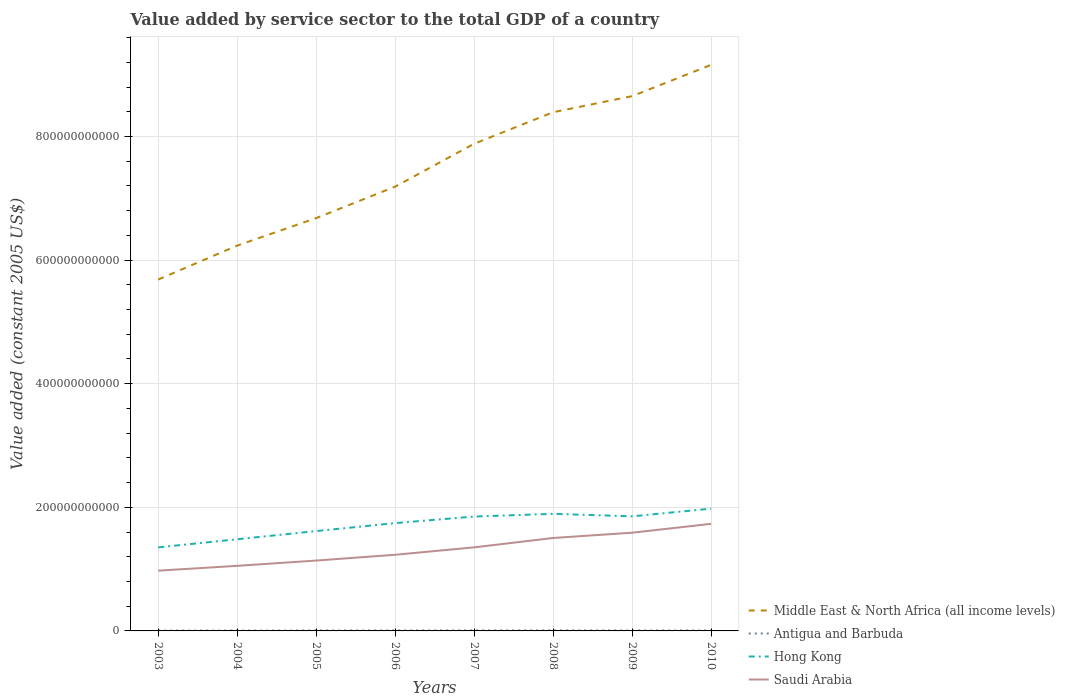How many different coloured lines are there?
Ensure brevity in your answer.  4. Does the line corresponding to Middle East & North Africa (all income levels) intersect with the line corresponding to Antigua and Barbuda?
Your answer should be very brief. No. Is the number of lines equal to the number of legend labels?
Make the answer very short. Yes. Across all years, what is the maximum value added by service sector in Antigua and Barbuda?
Your response must be concise. 6.45e+08. In which year was the value added by service sector in Saudi Arabia maximum?
Your answer should be very brief. 2003. What is the total value added by service sector in Antigua and Barbuda in the graph?
Offer a very short reply. -1.38e+08. What is the difference between the highest and the second highest value added by service sector in Hong Kong?
Your answer should be very brief. 6.27e+1. How many lines are there?
Make the answer very short. 4. What is the difference between two consecutive major ticks on the Y-axis?
Provide a short and direct response. 2.00e+11. Are the values on the major ticks of Y-axis written in scientific E-notation?
Give a very brief answer. No. Does the graph contain grids?
Your answer should be compact. Yes. How many legend labels are there?
Offer a terse response. 4. How are the legend labels stacked?
Your answer should be very brief. Vertical. What is the title of the graph?
Keep it short and to the point. Value added by service sector to the total GDP of a country. What is the label or title of the X-axis?
Give a very brief answer. Years. What is the label or title of the Y-axis?
Provide a short and direct response. Value added (constant 2005 US$). What is the Value added (constant 2005 US$) in Middle East & North Africa (all income levels) in 2003?
Offer a terse response. 5.69e+11. What is the Value added (constant 2005 US$) of Antigua and Barbuda in 2003?
Ensure brevity in your answer.  6.45e+08. What is the Value added (constant 2005 US$) in Hong Kong in 2003?
Keep it short and to the point. 1.35e+11. What is the Value added (constant 2005 US$) in Saudi Arabia in 2003?
Offer a terse response. 9.75e+1. What is the Value added (constant 2005 US$) of Middle East & North Africa (all income levels) in 2004?
Give a very brief answer. 6.23e+11. What is the Value added (constant 2005 US$) of Antigua and Barbuda in 2004?
Keep it short and to the point. 6.69e+08. What is the Value added (constant 2005 US$) in Hong Kong in 2004?
Provide a short and direct response. 1.48e+11. What is the Value added (constant 2005 US$) in Saudi Arabia in 2004?
Make the answer very short. 1.05e+11. What is the Value added (constant 2005 US$) in Middle East & North Africa (all income levels) in 2005?
Keep it short and to the point. 6.68e+11. What is the Value added (constant 2005 US$) of Antigua and Barbuda in 2005?
Provide a succinct answer. 7.00e+08. What is the Value added (constant 2005 US$) of Hong Kong in 2005?
Provide a succinct answer. 1.62e+11. What is the Value added (constant 2005 US$) of Saudi Arabia in 2005?
Give a very brief answer. 1.14e+11. What is the Value added (constant 2005 US$) in Middle East & North Africa (all income levels) in 2006?
Your answer should be very brief. 7.19e+11. What is the Value added (constant 2005 US$) in Antigua and Barbuda in 2006?
Your answer should be compact. 7.54e+08. What is the Value added (constant 2005 US$) of Hong Kong in 2006?
Your answer should be compact. 1.74e+11. What is the Value added (constant 2005 US$) in Saudi Arabia in 2006?
Give a very brief answer. 1.23e+11. What is the Value added (constant 2005 US$) of Middle East & North Africa (all income levels) in 2007?
Your answer should be very brief. 7.88e+11. What is the Value added (constant 2005 US$) in Antigua and Barbuda in 2007?
Keep it short and to the point. 8.07e+08. What is the Value added (constant 2005 US$) of Hong Kong in 2007?
Offer a very short reply. 1.85e+11. What is the Value added (constant 2005 US$) of Saudi Arabia in 2007?
Your answer should be very brief. 1.35e+11. What is the Value added (constant 2005 US$) of Middle East & North Africa (all income levels) in 2008?
Ensure brevity in your answer.  8.39e+11. What is the Value added (constant 2005 US$) in Antigua and Barbuda in 2008?
Offer a very short reply. 8.23e+08. What is the Value added (constant 2005 US$) of Hong Kong in 2008?
Provide a succinct answer. 1.89e+11. What is the Value added (constant 2005 US$) in Saudi Arabia in 2008?
Ensure brevity in your answer.  1.50e+11. What is the Value added (constant 2005 US$) of Middle East & North Africa (all income levels) in 2009?
Your response must be concise. 8.65e+11. What is the Value added (constant 2005 US$) in Antigua and Barbuda in 2009?
Your answer should be compact. 7.27e+08. What is the Value added (constant 2005 US$) of Hong Kong in 2009?
Provide a succinct answer. 1.85e+11. What is the Value added (constant 2005 US$) of Saudi Arabia in 2009?
Offer a terse response. 1.59e+11. What is the Value added (constant 2005 US$) of Middle East & North Africa (all income levels) in 2010?
Provide a succinct answer. 9.16e+11. What is the Value added (constant 2005 US$) in Antigua and Barbuda in 2010?
Give a very brief answer. 7.00e+08. What is the Value added (constant 2005 US$) of Hong Kong in 2010?
Keep it short and to the point. 1.98e+11. What is the Value added (constant 2005 US$) of Saudi Arabia in 2010?
Your answer should be compact. 1.73e+11. Across all years, what is the maximum Value added (constant 2005 US$) of Middle East & North Africa (all income levels)?
Your answer should be compact. 9.16e+11. Across all years, what is the maximum Value added (constant 2005 US$) in Antigua and Barbuda?
Your answer should be very brief. 8.23e+08. Across all years, what is the maximum Value added (constant 2005 US$) in Hong Kong?
Your answer should be compact. 1.98e+11. Across all years, what is the maximum Value added (constant 2005 US$) of Saudi Arabia?
Your response must be concise. 1.73e+11. Across all years, what is the minimum Value added (constant 2005 US$) of Middle East & North Africa (all income levels)?
Your answer should be very brief. 5.69e+11. Across all years, what is the minimum Value added (constant 2005 US$) of Antigua and Barbuda?
Keep it short and to the point. 6.45e+08. Across all years, what is the minimum Value added (constant 2005 US$) of Hong Kong?
Give a very brief answer. 1.35e+11. Across all years, what is the minimum Value added (constant 2005 US$) in Saudi Arabia?
Your response must be concise. 9.75e+1. What is the total Value added (constant 2005 US$) of Middle East & North Africa (all income levels) in the graph?
Your response must be concise. 5.99e+12. What is the total Value added (constant 2005 US$) in Antigua and Barbuda in the graph?
Your answer should be very brief. 5.83e+09. What is the total Value added (constant 2005 US$) in Hong Kong in the graph?
Keep it short and to the point. 1.38e+12. What is the total Value added (constant 2005 US$) in Saudi Arabia in the graph?
Offer a terse response. 1.06e+12. What is the difference between the Value added (constant 2005 US$) in Middle East & North Africa (all income levels) in 2003 and that in 2004?
Ensure brevity in your answer.  -5.49e+1. What is the difference between the Value added (constant 2005 US$) of Antigua and Barbuda in 2003 and that in 2004?
Your response must be concise. -2.36e+07. What is the difference between the Value added (constant 2005 US$) in Hong Kong in 2003 and that in 2004?
Your response must be concise. -1.32e+1. What is the difference between the Value added (constant 2005 US$) in Saudi Arabia in 2003 and that in 2004?
Provide a succinct answer. -7.80e+09. What is the difference between the Value added (constant 2005 US$) in Middle East & North Africa (all income levels) in 2003 and that in 2005?
Give a very brief answer. -9.94e+1. What is the difference between the Value added (constant 2005 US$) of Antigua and Barbuda in 2003 and that in 2005?
Give a very brief answer. -5.47e+07. What is the difference between the Value added (constant 2005 US$) in Hong Kong in 2003 and that in 2005?
Provide a succinct answer. -2.64e+1. What is the difference between the Value added (constant 2005 US$) of Saudi Arabia in 2003 and that in 2005?
Provide a short and direct response. -1.64e+1. What is the difference between the Value added (constant 2005 US$) of Middle East & North Africa (all income levels) in 2003 and that in 2006?
Provide a short and direct response. -1.50e+11. What is the difference between the Value added (constant 2005 US$) of Antigua and Barbuda in 2003 and that in 2006?
Give a very brief answer. -1.09e+08. What is the difference between the Value added (constant 2005 US$) of Hong Kong in 2003 and that in 2006?
Provide a succinct answer. -3.93e+1. What is the difference between the Value added (constant 2005 US$) in Saudi Arabia in 2003 and that in 2006?
Make the answer very short. -2.57e+1. What is the difference between the Value added (constant 2005 US$) of Middle East & North Africa (all income levels) in 2003 and that in 2007?
Make the answer very short. -2.20e+11. What is the difference between the Value added (constant 2005 US$) of Antigua and Barbuda in 2003 and that in 2007?
Ensure brevity in your answer.  -1.61e+08. What is the difference between the Value added (constant 2005 US$) of Hong Kong in 2003 and that in 2007?
Provide a short and direct response. -4.99e+1. What is the difference between the Value added (constant 2005 US$) of Saudi Arabia in 2003 and that in 2007?
Your response must be concise. -3.77e+1. What is the difference between the Value added (constant 2005 US$) of Middle East & North Africa (all income levels) in 2003 and that in 2008?
Give a very brief answer. -2.71e+11. What is the difference between the Value added (constant 2005 US$) of Antigua and Barbuda in 2003 and that in 2008?
Offer a very short reply. -1.78e+08. What is the difference between the Value added (constant 2005 US$) of Hong Kong in 2003 and that in 2008?
Your response must be concise. -5.43e+1. What is the difference between the Value added (constant 2005 US$) in Saudi Arabia in 2003 and that in 2008?
Your answer should be very brief. -5.29e+1. What is the difference between the Value added (constant 2005 US$) of Middle East & North Africa (all income levels) in 2003 and that in 2009?
Your response must be concise. -2.97e+11. What is the difference between the Value added (constant 2005 US$) in Antigua and Barbuda in 2003 and that in 2009?
Offer a terse response. -8.20e+07. What is the difference between the Value added (constant 2005 US$) in Hong Kong in 2003 and that in 2009?
Your response must be concise. -5.02e+1. What is the difference between the Value added (constant 2005 US$) in Saudi Arabia in 2003 and that in 2009?
Give a very brief answer. -6.14e+1. What is the difference between the Value added (constant 2005 US$) in Middle East & North Africa (all income levels) in 2003 and that in 2010?
Offer a very short reply. -3.47e+11. What is the difference between the Value added (constant 2005 US$) in Antigua and Barbuda in 2003 and that in 2010?
Provide a short and direct response. -5.50e+07. What is the difference between the Value added (constant 2005 US$) in Hong Kong in 2003 and that in 2010?
Your response must be concise. -6.27e+1. What is the difference between the Value added (constant 2005 US$) of Saudi Arabia in 2003 and that in 2010?
Offer a very short reply. -7.58e+1. What is the difference between the Value added (constant 2005 US$) in Middle East & North Africa (all income levels) in 2004 and that in 2005?
Your answer should be very brief. -4.45e+1. What is the difference between the Value added (constant 2005 US$) in Antigua and Barbuda in 2004 and that in 2005?
Make the answer very short. -3.11e+07. What is the difference between the Value added (constant 2005 US$) in Hong Kong in 2004 and that in 2005?
Offer a very short reply. -1.32e+1. What is the difference between the Value added (constant 2005 US$) in Saudi Arabia in 2004 and that in 2005?
Ensure brevity in your answer.  -8.56e+09. What is the difference between the Value added (constant 2005 US$) of Middle East & North Africa (all income levels) in 2004 and that in 2006?
Offer a very short reply. -9.54e+1. What is the difference between the Value added (constant 2005 US$) of Antigua and Barbuda in 2004 and that in 2006?
Provide a short and direct response. -8.52e+07. What is the difference between the Value added (constant 2005 US$) in Hong Kong in 2004 and that in 2006?
Offer a terse response. -2.61e+1. What is the difference between the Value added (constant 2005 US$) of Saudi Arabia in 2004 and that in 2006?
Make the answer very short. -1.79e+1. What is the difference between the Value added (constant 2005 US$) of Middle East & North Africa (all income levels) in 2004 and that in 2007?
Provide a succinct answer. -1.65e+11. What is the difference between the Value added (constant 2005 US$) in Antigua and Barbuda in 2004 and that in 2007?
Offer a very short reply. -1.38e+08. What is the difference between the Value added (constant 2005 US$) of Hong Kong in 2004 and that in 2007?
Offer a very short reply. -3.67e+1. What is the difference between the Value added (constant 2005 US$) in Saudi Arabia in 2004 and that in 2007?
Offer a terse response. -2.99e+1. What is the difference between the Value added (constant 2005 US$) in Middle East & North Africa (all income levels) in 2004 and that in 2008?
Give a very brief answer. -2.16e+11. What is the difference between the Value added (constant 2005 US$) in Antigua and Barbuda in 2004 and that in 2008?
Offer a terse response. -1.55e+08. What is the difference between the Value added (constant 2005 US$) in Hong Kong in 2004 and that in 2008?
Keep it short and to the point. -4.11e+1. What is the difference between the Value added (constant 2005 US$) of Saudi Arabia in 2004 and that in 2008?
Keep it short and to the point. -4.51e+1. What is the difference between the Value added (constant 2005 US$) in Middle East & North Africa (all income levels) in 2004 and that in 2009?
Keep it short and to the point. -2.42e+11. What is the difference between the Value added (constant 2005 US$) in Antigua and Barbuda in 2004 and that in 2009?
Your answer should be very brief. -5.84e+07. What is the difference between the Value added (constant 2005 US$) in Hong Kong in 2004 and that in 2009?
Your response must be concise. -3.71e+1. What is the difference between the Value added (constant 2005 US$) of Saudi Arabia in 2004 and that in 2009?
Your answer should be compact. -5.36e+1. What is the difference between the Value added (constant 2005 US$) in Middle East & North Africa (all income levels) in 2004 and that in 2010?
Make the answer very short. -2.92e+11. What is the difference between the Value added (constant 2005 US$) in Antigua and Barbuda in 2004 and that in 2010?
Make the answer very short. -3.14e+07. What is the difference between the Value added (constant 2005 US$) in Hong Kong in 2004 and that in 2010?
Give a very brief answer. -4.95e+1. What is the difference between the Value added (constant 2005 US$) of Saudi Arabia in 2004 and that in 2010?
Offer a very short reply. -6.80e+1. What is the difference between the Value added (constant 2005 US$) of Middle East & North Africa (all income levels) in 2005 and that in 2006?
Your answer should be compact. -5.10e+1. What is the difference between the Value added (constant 2005 US$) in Antigua and Barbuda in 2005 and that in 2006?
Make the answer very short. -5.41e+07. What is the difference between the Value added (constant 2005 US$) of Hong Kong in 2005 and that in 2006?
Keep it short and to the point. -1.29e+1. What is the difference between the Value added (constant 2005 US$) of Saudi Arabia in 2005 and that in 2006?
Make the answer very short. -9.36e+09. What is the difference between the Value added (constant 2005 US$) in Middle East & North Africa (all income levels) in 2005 and that in 2007?
Your answer should be compact. -1.20e+11. What is the difference between the Value added (constant 2005 US$) of Antigua and Barbuda in 2005 and that in 2007?
Offer a terse response. -1.07e+08. What is the difference between the Value added (constant 2005 US$) in Hong Kong in 2005 and that in 2007?
Offer a terse response. -2.35e+1. What is the difference between the Value added (constant 2005 US$) of Saudi Arabia in 2005 and that in 2007?
Offer a terse response. -2.14e+1. What is the difference between the Value added (constant 2005 US$) of Middle East & North Africa (all income levels) in 2005 and that in 2008?
Your answer should be very brief. -1.71e+11. What is the difference between the Value added (constant 2005 US$) of Antigua and Barbuda in 2005 and that in 2008?
Give a very brief answer. -1.24e+08. What is the difference between the Value added (constant 2005 US$) in Hong Kong in 2005 and that in 2008?
Ensure brevity in your answer.  -2.79e+1. What is the difference between the Value added (constant 2005 US$) in Saudi Arabia in 2005 and that in 2008?
Give a very brief answer. -3.65e+1. What is the difference between the Value added (constant 2005 US$) of Middle East & North Africa (all income levels) in 2005 and that in 2009?
Offer a very short reply. -1.97e+11. What is the difference between the Value added (constant 2005 US$) in Antigua and Barbuda in 2005 and that in 2009?
Offer a very short reply. -2.74e+07. What is the difference between the Value added (constant 2005 US$) in Hong Kong in 2005 and that in 2009?
Provide a succinct answer. -2.39e+1. What is the difference between the Value added (constant 2005 US$) of Saudi Arabia in 2005 and that in 2009?
Your response must be concise. -4.51e+1. What is the difference between the Value added (constant 2005 US$) in Middle East & North Africa (all income levels) in 2005 and that in 2010?
Keep it short and to the point. -2.48e+11. What is the difference between the Value added (constant 2005 US$) in Antigua and Barbuda in 2005 and that in 2010?
Your answer should be compact. -2.72e+05. What is the difference between the Value added (constant 2005 US$) of Hong Kong in 2005 and that in 2010?
Give a very brief answer. -3.63e+1. What is the difference between the Value added (constant 2005 US$) of Saudi Arabia in 2005 and that in 2010?
Your response must be concise. -5.94e+1. What is the difference between the Value added (constant 2005 US$) in Middle East & North Africa (all income levels) in 2006 and that in 2007?
Your response must be concise. -6.94e+1. What is the difference between the Value added (constant 2005 US$) in Antigua and Barbuda in 2006 and that in 2007?
Ensure brevity in your answer.  -5.26e+07. What is the difference between the Value added (constant 2005 US$) in Hong Kong in 2006 and that in 2007?
Your response must be concise. -1.06e+1. What is the difference between the Value added (constant 2005 US$) of Saudi Arabia in 2006 and that in 2007?
Give a very brief answer. -1.20e+1. What is the difference between the Value added (constant 2005 US$) in Middle East & North Africa (all income levels) in 2006 and that in 2008?
Keep it short and to the point. -1.20e+11. What is the difference between the Value added (constant 2005 US$) of Antigua and Barbuda in 2006 and that in 2008?
Provide a short and direct response. -6.95e+07. What is the difference between the Value added (constant 2005 US$) of Hong Kong in 2006 and that in 2008?
Your response must be concise. -1.50e+1. What is the difference between the Value added (constant 2005 US$) of Saudi Arabia in 2006 and that in 2008?
Provide a short and direct response. -2.72e+1. What is the difference between the Value added (constant 2005 US$) of Middle East & North Africa (all income levels) in 2006 and that in 2009?
Provide a succinct answer. -1.46e+11. What is the difference between the Value added (constant 2005 US$) in Antigua and Barbuda in 2006 and that in 2009?
Offer a terse response. 2.68e+07. What is the difference between the Value added (constant 2005 US$) in Hong Kong in 2006 and that in 2009?
Your answer should be compact. -1.10e+1. What is the difference between the Value added (constant 2005 US$) of Saudi Arabia in 2006 and that in 2009?
Offer a terse response. -3.57e+1. What is the difference between the Value added (constant 2005 US$) in Middle East & North Africa (all income levels) in 2006 and that in 2010?
Give a very brief answer. -1.97e+11. What is the difference between the Value added (constant 2005 US$) of Antigua and Barbuda in 2006 and that in 2010?
Keep it short and to the point. 5.38e+07. What is the difference between the Value added (constant 2005 US$) of Hong Kong in 2006 and that in 2010?
Offer a terse response. -2.34e+1. What is the difference between the Value added (constant 2005 US$) in Saudi Arabia in 2006 and that in 2010?
Your answer should be very brief. -5.01e+1. What is the difference between the Value added (constant 2005 US$) in Middle East & North Africa (all income levels) in 2007 and that in 2008?
Offer a very short reply. -5.10e+1. What is the difference between the Value added (constant 2005 US$) of Antigua and Barbuda in 2007 and that in 2008?
Your answer should be compact. -1.68e+07. What is the difference between the Value added (constant 2005 US$) of Hong Kong in 2007 and that in 2008?
Your response must be concise. -4.39e+09. What is the difference between the Value added (constant 2005 US$) of Saudi Arabia in 2007 and that in 2008?
Give a very brief answer. -1.52e+1. What is the difference between the Value added (constant 2005 US$) of Middle East & North Africa (all income levels) in 2007 and that in 2009?
Provide a succinct answer. -7.70e+1. What is the difference between the Value added (constant 2005 US$) in Antigua and Barbuda in 2007 and that in 2009?
Ensure brevity in your answer.  7.94e+07. What is the difference between the Value added (constant 2005 US$) of Hong Kong in 2007 and that in 2009?
Offer a terse response. -3.63e+08. What is the difference between the Value added (constant 2005 US$) of Saudi Arabia in 2007 and that in 2009?
Your response must be concise. -2.37e+1. What is the difference between the Value added (constant 2005 US$) of Middle East & North Africa (all income levels) in 2007 and that in 2010?
Your answer should be very brief. -1.28e+11. What is the difference between the Value added (constant 2005 US$) of Antigua and Barbuda in 2007 and that in 2010?
Your answer should be compact. 1.06e+08. What is the difference between the Value added (constant 2005 US$) of Hong Kong in 2007 and that in 2010?
Your answer should be compact. -1.28e+1. What is the difference between the Value added (constant 2005 US$) of Saudi Arabia in 2007 and that in 2010?
Provide a short and direct response. -3.81e+1. What is the difference between the Value added (constant 2005 US$) in Middle East & North Africa (all income levels) in 2008 and that in 2009?
Make the answer very short. -2.60e+1. What is the difference between the Value added (constant 2005 US$) of Antigua and Barbuda in 2008 and that in 2009?
Ensure brevity in your answer.  9.62e+07. What is the difference between the Value added (constant 2005 US$) in Hong Kong in 2008 and that in 2009?
Give a very brief answer. 4.03e+09. What is the difference between the Value added (constant 2005 US$) in Saudi Arabia in 2008 and that in 2009?
Provide a short and direct response. -8.54e+09. What is the difference between the Value added (constant 2005 US$) in Middle East & North Africa (all income levels) in 2008 and that in 2010?
Give a very brief answer. -7.66e+1. What is the difference between the Value added (constant 2005 US$) in Antigua and Barbuda in 2008 and that in 2010?
Your response must be concise. 1.23e+08. What is the difference between the Value added (constant 2005 US$) of Hong Kong in 2008 and that in 2010?
Provide a succinct answer. -8.41e+09. What is the difference between the Value added (constant 2005 US$) of Saudi Arabia in 2008 and that in 2010?
Provide a succinct answer. -2.29e+1. What is the difference between the Value added (constant 2005 US$) in Middle East & North Africa (all income levels) in 2009 and that in 2010?
Ensure brevity in your answer.  -5.06e+1. What is the difference between the Value added (constant 2005 US$) in Antigua and Barbuda in 2009 and that in 2010?
Make the answer very short. 2.71e+07. What is the difference between the Value added (constant 2005 US$) in Hong Kong in 2009 and that in 2010?
Offer a very short reply. -1.24e+1. What is the difference between the Value added (constant 2005 US$) of Saudi Arabia in 2009 and that in 2010?
Give a very brief answer. -1.43e+1. What is the difference between the Value added (constant 2005 US$) of Middle East & North Africa (all income levels) in 2003 and the Value added (constant 2005 US$) of Antigua and Barbuda in 2004?
Make the answer very short. 5.68e+11. What is the difference between the Value added (constant 2005 US$) of Middle East & North Africa (all income levels) in 2003 and the Value added (constant 2005 US$) of Hong Kong in 2004?
Your answer should be compact. 4.20e+11. What is the difference between the Value added (constant 2005 US$) in Middle East & North Africa (all income levels) in 2003 and the Value added (constant 2005 US$) in Saudi Arabia in 2004?
Keep it short and to the point. 4.63e+11. What is the difference between the Value added (constant 2005 US$) of Antigua and Barbuda in 2003 and the Value added (constant 2005 US$) of Hong Kong in 2004?
Offer a terse response. -1.48e+11. What is the difference between the Value added (constant 2005 US$) in Antigua and Barbuda in 2003 and the Value added (constant 2005 US$) in Saudi Arabia in 2004?
Provide a short and direct response. -1.05e+11. What is the difference between the Value added (constant 2005 US$) of Hong Kong in 2003 and the Value added (constant 2005 US$) of Saudi Arabia in 2004?
Offer a very short reply. 2.99e+1. What is the difference between the Value added (constant 2005 US$) in Middle East & North Africa (all income levels) in 2003 and the Value added (constant 2005 US$) in Antigua and Barbuda in 2005?
Provide a succinct answer. 5.68e+11. What is the difference between the Value added (constant 2005 US$) of Middle East & North Africa (all income levels) in 2003 and the Value added (constant 2005 US$) of Hong Kong in 2005?
Ensure brevity in your answer.  4.07e+11. What is the difference between the Value added (constant 2005 US$) in Middle East & North Africa (all income levels) in 2003 and the Value added (constant 2005 US$) in Saudi Arabia in 2005?
Your answer should be compact. 4.55e+11. What is the difference between the Value added (constant 2005 US$) of Antigua and Barbuda in 2003 and the Value added (constant 2005 US$) of Hong Kong in 2005?
Your answer should be very brief. -1.61e+11. What is the difference between the Value added (constant 2005 US$) in Antigua and Barbuda in 2003 and the Value added (constant 2005 US$) in Saudi Arabia in 2005?
Offer a very short reply. -1.13e+11. What is the difference between the Value added (constant 2005 US$) in Hong Kong in 2003 and the Value added (constant 2005 US$) in Saudi Arabia in 2005?
Make the answer very short. 2.13e+1. What is the difference between the Value added (constant 2005 US$) of Middle East & North Africa (all income levels) in 2003 and the Value added (constant 2005 US$) of Antigua and Barbuda in 2006?
Make the answer very short. 5.68e+11. What is the difference between the Value added (constant 2005 US$) of Middle East & North Africa (all income levels) in 2003 and the Value added (constant 2005 US$) of Hong Kong in 2006?
Provide a succinct answer. 3.94e+11. What is the difference between the Value added (constant 2005 US$) in Middle East & North Africa (all income levels) in 2003 and the Value added (constant 2005 US$) in Saudi Arabia in 2006?
Offer a very short reply. 4.45e+11. What is the difference between the Value added (constant 2005 US$) in Antigua and Barbuda in 2003 and the Value added (constant 2005 US$) in Hong Kong in 2006?
Make the answer very short. -1.74e+11. What is the difference between the Value added (constant 2005 US$) of Antigua and Barbuda in 2003 and the Value added (constant 2005 US$) of Saudi Arabia in 2006?
Give a very brief answer. -1.23e+11. What is the difference between the Value added (constant 2005 US$) in Hong Kong in 2003 and the Value added (constant 2005 US$) in Saudi Arabia in 2006?
Provide a short and direct response. 1.20e+1. What is the difference between the Value added (constant 2005 US$) in Middle East & North Africa (all income levels) in 2003 and the Value added (constant 2005 US$) in Antigua and Barbuda in 2007?
Give a very brief answer. 5.68e+11. What is the difference between the Value added (constant 2005 US$) in Middle East & North Africa (all income levels) in 2003 and the Value added (constant 2005 US$) in Hong Kong in 2007?
Give a very brief answer. 3.83e+11. What is the difference between the Value added (constant 2005 US$) in Middle East & North Africa (all income levels) in 2003 and the Value added (constant 2005 US$) in Saudi Arabia in 2007?
Offer a terse response. 4.33e+11. What is the difference between the Value added (constant 2005 US$) of Antigua and Barbuda in 2003 and the Value added (constant 2005 US$) of Hong Kong in 2007?
Give a very brief answer. -1.84e+11. What is the difference between the Value added (constant 2005 US$) in Antigua and Barbuda in 2003 and the Value added (constant 2005 US$) in Saudi Arabia in 2007?
Ensure brevity in your answer.  -1.35e+11. What is the difference between the Value added (constant 2005 US$) in Hong Kong in 2003 and the Value added (constant 2005 US$) in Saudi Arabia in 2007?
Offer a terse response. -2.84e+07. What is the difference between the Value added (constant 2005 US$) of Middle East & North Africa (all income levels) in 2003 and the Value added (constant 2005 US$) of Antigua and Barbuda in 2008?
Provide a succinct answer. 5.68e+11. What is the difference between the Value added (constant 2005 US$) in Middle East & North Africa (all income levels) in 2003 and the Value added (constant 2005 US$) in Hong Kong in 2008?
Offer a very short reply. 3.79e+11. What is the difference between the Value added (constant 2005 US$) in Middle East & North Africa (all income levels) in 2003 and the Value added (constant 2005 US$) in Saudi Arabia in 2008?
Provide a succinct answer. 4.18e+11. What is the difference between the Value added (constant 2005 US$) in Antigua and Barbuda in 2003 and the Value added (constant 2005 US$) in Hong Kong in 2008?
Your answer should be very brief. -1.89e+11. What is the difference between the Value added (constant 2005 US$) in Antigua and Barbuda in 2003 and the Value added (constant 2005 US$) in Saudi Arabia in 2008?
Ensure brevity in your answer.  -1.50e+11. What is the difference between the Value added (constant 2005 US$) of Hong Kong in 2003 and the Value added (constant 2005 US$) of Saudi Arabia in 2008?
Ensure brevity in your answer.  -1.52e+1. What is the difference between the Value added (constant 2005 US$) in Middle East & North Africa (all income levels) in 2003 and the Value added (constant 2005 US$) in Antigua and Barbuda in 2009?
Ensure brevity in your answer.  5.68e+11. What is the difference between the Value added (constant 2005 US$) of Middle East & North Africa (all income levels) in 2003 and the Value added (constant 2005 US$) of Hong Kong in 2009?
Keep it short and to the point. 3.83e+11. What is the difference between the Value added (constant 2005 US$) of Middle East & North Africa (all income levels) in 2003 and the Value added (constant 2005 US$) of Saudi Arabia in 2009?
Make the answer very short. 4.10e+11. What is the difference between the Value added (constant 2005 US$) of Antigua and Barbuda in 2003 and the Value added (constant 2005 US$) of Hong Kong in 2009?
Your answer should be compact. -1.85e+11. What is the difference between the Value added (constant 2005 US$) of Antigua and Barbuda in 2003 and the Value added (constant 2005 US$) of Saudi Arabia in 2009?
Provide a short and direct response. -1.58e+11. What is the difference between the Value added (constant 2005 US$) of Hong Kong in 2003 and the Value added (constant 2005 US$) of Saudi Arabia in 2009?
Offer a terse response. -2.37e+1. What is the difference between the Value added (constant 2005 US$) in Middle East & North Africa (all income levels) in 2003 and the Value added (constant 2005 US$) in Antigua and Barbuda in 2010?
Your response must be concise. 5.68e+11. What is the difference between the Value added (constant 2005 US$) of Middle East & North Africa (all income levels) in 2003 and the Value added (constant 2005 US$) of Hong Kong in 2010?
Provide a short and direct response. 3.71e+11. What is the difference between the Value added (constant 2005 US$) in Middle East & North Africa (all income levels) in 2003 and the Value added (constant 2005 US$) in Saudi Arabia in 2010?
Offer a very short reply. 3.95e+11. What is the difference between the Value added (constant 2005 US$) in Antigua and Barbuda in 2003 and the Value added (constant 2005 US$) in Hong Kong in 2010?
Ensure brevity in your answer.  -1.97e+11. What is the difference between the Value added (constant 2005 US$) in Antigua and Barbuda in 2003 and the Value added (constant 2005 US$) in Saudi Arabia in 2010?
Offer a terse response. -1.73e+11. What is the difference between the Value added (constant 2005 US$) of Hong Kong in 2003 and the Value added (constant 2005 US$) of Saudi Arabia in 2010?
Provide a succinct answer. -3.81e+1. What is the difference between the Value added (constant 2005 US$) of Middle East & North Africa (all income levels) in 2004 and the Value added (constant 2005 US$) of Antigua and Barbuda in 2005?
Offer a very short reply. 6.23e+11. What is the difference between the Value added (constant 2005 US$) of Middle East & North Africa (all income levels) in 2004 and the Value added (constant 2005 US$) of Hong Kong in 2005?
Your response must be concise. 4.62e+11. What is the difference between the Value added (constant 2005 US$) in Middle East & North Africa (all income levels) in 2004 and the Value added (constant 2005 US$) in Saudi Arabia in 2005?
Provide a short and direct response. 5.10e+11. What is the difference between the Value added (constant 2005 US$) in Antigua and Barbuda in 2004 and the Value added (constant 2005 US$) in Hong Kong in 2005?
Give a very brief answer. -1.61e+11. What is the difference between the Value added (constant 2005 US$) of Antigua and Barbuda in 2004 and the Value added (constant 2005 US$) of Saudi Arabia in 2005?
Your answer should be very brief. -1.13e+11. What is the difference between the Value added (constant 2005 US$) in Hong Kong in 2004 and the Value added (constant 2005 US$) in Saudi Arabia in 2005?
Keep it short and to the point. 3.45e+1. What is the difference between the Value added (constant 2005 US$) in Middle East & North Africa (all income levels) in 2004 and the Value added (constant 2005 US$) in Antigua and Barbuda in 2006?
Your response must be concise. 6.23e+11. What is the difference between the Value added (constant 2005 US$) of Middle East & North Africa (all income levels) in 2004 and the Value added (constant 2005 US$) of Hong Kong in 2006?
Provide a short and direct response. 4.49e+11. What is the difference between the Value added (constant 2005 US$) of Middle East & North Africa (all income levels) in 2004 and the Value added (constant 2005 US$) of Saudi Arabia in 2006?
Your answer should be very brief. 5.00e+11. What is the difference between the Value added (constant 2005 US$) of Antigua and Barbuda in 2004 and the Value added (constant 2005 US$) of Hong Kong in 2006?
Ensure brevity in your answer.  -1.74e+11. What is the difference between the Value added (constant 2005 US$) in Antigua and Barbuda in 2004 and the Value added (constant 2005 US$) in Saudi Arabia in 2006?
Give a very brief answer. -1.23e+11. What is the difference between the Value added (constant 2005 US$) in Hong Kong in 2004 and the Value added (constant 2005 US$) in Saudi Arabia in 2006?
Provide a succinct answer. 2.51e+1. What is the difference between the Value added (constant 2005 US$) in Middle East & North Africa (all income levels) in 2004 and the Value added (constant 2005 US$) in Antigua and Barbuda in 2007?
Make the answer very short. 6.23e+11. What is the difference between the Value added (constant 2005 US$) in Middle East & North Africa (all income levels) in 2004 and the Value added (constant 2005 US$) in Hong Kong in 2007?
Offer a very short reply. 4.38e+11. What is the difference between the Value added (constant 2005 US$) in Middle East & North Africa (all income levels) in 2004 and the Value added (constant 2005 US$) in Saudi Arabia in 2007?
Provide a short and direct response. 4.88e+11. What is the difference between the Value added (constant 2005 US$) of Antigua and Barbuda in 2004 and the Value added (constant 2005 US$) of Hong Kong in 2007?
Keep it short and to the point. -1.84e+11. What is the difference between the Value added (constant 2005 US$) in Antigua and Barbuda in 2004 and the Value added (constant 2005 US$) in Saudi Arabia in 2007?
Your response must be concise. -1.35e+11. What is the difference between the Value added (constant 2005 US$) in Hong Kong in 2004 and the Value added (constant 2005 US$) in Saudi Arabia in 2007?
Your answer should be very brief. 1.31e+1. What is the difference between the Value added (constant 2005 US$) of Middle East & North Africa (all income levels) in 2004 and the Value added (constant 2005 US$) of Antigua and Barbuda in 2008?
Provide a succinct answer. 6.23e+11. What is the difference between the Value added (constant 2005 US$) of Middle East & North Africa (all income levels) in 2004 and the Value added (constant 2005 US$) of Hong Kong in 2008?
Provide a short and direct response. 4.34e+11. What is the difference between the Value added (constant 2005 US$) of Middle East & North Africa (all income levels) in 2004 and the Value added (constant 2005 US$) of Saudi Arabia in 2008?
Provide a succinct answer. 4.73e+11. What is the difference between the Value added (constant 2005 US$) in Antigua and Barbuda in 2004 and the Value added (constant 2005 US$) in Hong Kong in 2008?
Ensure brevity in your answer.  -1.89e+11. What is the difference between the Value added (constant 2005 US$) of Antigua and Barbuda in 2004 and the Value added (constant 2005 US$) of Saudi Arabia in 2008?
Your answer should be compact. -1.50e+11. What is the difference between the Value added (constant 2005 US$) in Hong Kong in 2004 and the Value added (constant 2005 US$) in Saudi Arabia in 2008?
Offer a very short reply. -2.04e+09. What is the difference between the Value added (constant 2005 US$) in Middle East & North Africa (all income levels) in 2004 and the Value added (constant 2005 US$) in Antigua and Barbuda in 2009?
Give a very brief answer. 6.23e+11. What is the difference between the Value added (constant 2005 US$) in Middle East & North Africa (all income levels) in 2004 and the Value added (constant 2005 US$) in Hong Kong in 2009?
Your answer should be very brief. 4.38e+11. What is the difference between the Value added (constant 2005 US$) in Middle East & North Africa (all income levels) in 2004 and the Value added (constant 2005 US$) in Saudi Arabia in 2009?
Provide a short and direct response. 4.65e+11. What is the difference between the Value added (constant 2005 US$) in Antigua and Barbuda in 2004 and the Value added (constant 2005 US$) in Hong Kong in 2009?
Keep it short and to the point. -1.85e+11. What is the difference between the Value added (constant 2005 US$) of Antigua and Barbuda in 2004 and the Value added (constant 2005 US$) of Saudi Arabia in 2009?
Your answer should be compact. -1.58e+11. What is the difference between the Value added (constant 2005 US$) of Hong Kong in 2004 and the Value added (constant 2005 US$) of Saudi Arabia in 2009?
Offer a terse response. -1.06e+1. What is the difference between the Value added (constant 2005 US$) in Middle East & North Africa (all income levels) in 2004 and the Value added (constant 2005 US$) in Antigua and Barbuda in 2010?
Provide a short and direct response. 6.23e+11. What is the difference between the Value added (constant 2005 US$) in Middle East & North Africa (all income levels) in 2004 and the Value added (constant 2005 US$) in Hong Kong in 2010?
Your answer should be very brief. 4.26e+11. What is the difference between the Value added (constant 2005 US$) of Middle East & North Africa (all income levels) in 2004 and the Value added (constant 2005 US$) of Saudi Arabia in 2010?
Offer a terse response. 4.50e+11. What is the difference between the Value added (constant 2005 US$) of Antigua and Barbuda in 2004 and the Value added (constant 2005 US$) of Hong Kong in 2010?
Ensure brevity in your answer.  -1.97e+11. What is the difference between the Value added (constant 2005 US$) in Antigua and Barbuda in 2004 and the Value added (constant 2005 US$) in Saudi Arabia in 2010?
Provide a short and direct response. -1.73e+11. What is the difference between the Value added (constant 2005 US$) of Hong Kong in 2004 and the Value added (constant 2005 US$) of Saudi Arabia in 2010?
Give a very brief answer. -2.49e+1. What is the difference between the Value added (constant 2005 US$) in Middle East & North Africa (all income levels) in 2005 and the Value added (constant 2005 US$) in Antigua and Barbuda in 2006?
Ensure brevity in your answer.  6.67e+11. What is the difference between the Value added (constant 2005 US$) of Middle East & North Africa (all income levels) in 2005 and the Value added (constant 2005 US$) of Hong Kong in 2006?
Give a very brief answer. 4.93e+11. What is the difference between the Value added (constant 2005 US$) in Middle East & North Africa (all income levels) in 2005 and the Value added (constant 2005 US$) in Saudi Arabia in 2006?
Ensure brevity in your answer.  5.45e+11. What is the difference between the Value added (constant 2005 US$) in Antigua and Barbuda in 2005 and the Value added (constant 2005 US$) in Hong Kong in 2006?
Your response must be concise. -1.74e+11. What is the difference between the Value added (constant 2005 US$) in Antigua and Barbuda in 2005 and the Value added (constant 2005 US$) in Saudi Arabia in 2006?
Your response must be concise. -1.23e+11. What is the difference between the Value added (constant 2005 US$) in Hong Kong in 2005 and the Value added (constant 2005 US$) in Saudi Arabia in 2006?
Offer a terse response. 3.83e+1. What is the difference between the Value added (constant 2005 US$) of Middle East & North Africa (all income levels) in 2005 and the Value added (constant 2005 US$) of Antigua and Barbuda in 2007?
Your answer should be compact. 6.67e+11. What is the difference between the Value added (constant 2005 US$) of Middle East & North Africa (all income levels) in 2005 and the Value added (constant 2005 US$) of Hong Kong in 2007?
Give a very brief answer. 4.83e+11. What is the difference between the Value added (constant 2005 US$) in Middle East & North Africa (all income levels) in 2005 and the Value added (constant 2005 US$) in Saudi Arabia in 2007?
Make the answer very short. 5.33e+11. What is the difference between the Value added (constant 2005 US$) in Antigua and Barbuda in 2005 and the Value added (constant 2005 US$) in Hong Kong in 2007?
Provide a short and direct response. -1.84e+11. What is the difference between the Value added (constant 2005 US$) of Antigua and Barbuda in 2005 and the Value added (constant 2005 US$) of Saudi Arabia in 2007?
Give a very brief answer. -1.35e+11. What is the difference between the Value added (constant 2005 US$) in Hong Kong in 2005 and the Value added (constant 2005 US$) in Saudi Arabia in 2007?
Offer a very short reply. 2.63e+1. What is the difference between the Value added (constant 2005 US$) in Middle East & North Africa (all income levels) in 2005 and the Value added (constant 2005 US$) in Antigua and Barbuda in 2008?
Your answer should be compact. 6.67e+11. What is the difference between the Value added (constant 2005 US$) of Middle East & North Africa (all income levels) in 2005 and the Value added (constant 2005 US$) of Hong Kong in 2008?
Ensure brevity in your answer.  4.78e+11. What is the difference between the Value added (constant 2005 US$) in Middle East & North Africa (all income levels) in 2005 and the Value added (constant 2005 US$) in Saudi Arabia in 2008?
Your answer should be compact. 5.18e+11. What is the difference between the Value added (constant 2005 US$) of Antigua and Barbuda in 2005 and the Value added (constant 2005 US$) of Hong Kong in 2008?
Your response must be concise. -1.89e+11. What is the difference between the Value added (constant 2005 US$) in Antigua and Barbuda in 2005 and the Value added (constant 2005 US$) in Saudi Arabia in 2008?
Your answer should be very brief. -1.50e+11. What is the difference between the Value added (constant 2005 US$) in Hong Kong in 2005 and the Value added (constant 2005 US$) in Saudi Arabia in 2008?
Make the answer very short. 1.12e+1. What is the difference between the Value added (constant 2005 US$) in Middle East & North Africa (all income levels) in 2005 and the Value added (constant 2005 US$) in Antigua and Barbuda in 2009?
Offer a very short reply. 6.67e+11. What is the difference between the Value added (constant 2005 US$) of Middle East & North Africa (all income levels) in 2005 and the Value added (constant 2005 US$) of Hong Kong in 2009?
Give a very brief answer. 4.83e+11. What is the difference between the Value added (constant 2005 US$) in Middle East & North Africa (all income levels) in 2005 and the Value added (constant 2005 US$) in Saudi Arabia in 2009?
Your answer should be compact. 5.09e+11. What is the difference between the Value added (constant 2005 US$) of Antigua and Barbuda in 2005 and the Value added (constant 2005 US$) of Hong Kong in 2009?
Keep it short and to the point. -1.85e+11. What is the difference between the Value added (constant 2005 US$) of Antigua and Barbuda in 2005 and the Value added (constant 2005 US$) of Saudi Arabia in 2009?
Give a very brief answer. -1.58e+11. What is the difference between the Value added (constant 2005 US$) in Hong Kong in 2005 and the Value added (constant 2005 US$) in Saudi Arabia in 2009?
Provide a succinct answer. 2.63e+09. What is the difference between the Value added (constant 2005 US$) of Middle East & North Africa (all income levels) in 2005 and the Value added (constant 2005 US$) of Antigua and Barbuda in 2010?
Your answer should be compact. 6.67e+11. What is the difference between the Value added (constant 2005 US$) in Middle East & North Africa (all income levels) in 2005 and the Value added (constant 2005 US$) in Hong Kong in 2010?
Provide a short and direct response. 4.70e+11. What is the difference between the Value added (constant 2005 US$) of Middle East & North Africa (all income levels) in 2005 and the Value added (constant 2005 US$) of Saudi Arabia in 2010?
Your answer should be compact. 4.95e+11. What is the difference between the Value added (constant 2005 US$) in Antigua and Barbuda in 2005 and the Value added (constant 2005 US$) in Hong Kong in 2010?
Your answer should be compact. -1.97e+11. What is the difference between the Value added (constant 2005 US$) of Antigua and Barbuda in 2005 and the Value added (constant 2005 US$) of Saudi Arabia in 2010?
Your answer should be compact. -1.73e+11. What is the difference between the Value added (constant 2005 US$) of Hong Kong in 2005 and the Value added (constant 2005 US$) of Saudi Arabia in 2010?
Your answer should be compact. -1.17e+1. What is the difference between the Value added (constant 2005 US$) of Middle East & North Africa (all income levels) in 2006 and the Value added (constant 2005 US$) of Antigua and Barbuda in 2007?
Ensure brevity in your answer.  7.18e+11. What is the difference between the Value added (constant 2005 US$) in Middle East & North Africa (all income levels) in 2006 and the Value added (constant 2005 US$) in Hong Kong in 2007?
Offer a very short reply. 5.34e+11. What is the difference between the Value added (constant 2005 US$) of Middle East & North Africa (all income levels) in 2006 and the Value added (constant 2005 US$) of Saudi Arabia in 2007?
Provide a succinct answer. 5.84e+11. What is the difference between the Value added (constant 2005 US$) of Antigua and Barbuda in 2006 and the Value added (constant 2005 US$) of Hong Kong in 2007?
Your response must be concise. -1.84e+11. What is the difference between the Value added (constant 2005 US$) of Antigua and Barbuda in 2006 and the Value added (constant 2005 US$) of Saudi Arabia in 2007?
Ensure brevity in your answer.  -1.34e+11. What is the difference between the Value added (constant 2005 US$) of Hong Kong in 2006 and the Value added (constant 2005 US$) of Saudi Arabia in 2007?
Provide a succinct answer. 3.93e+1. What is the difference between the Value added (constant 2005 US$) of Middle East & North Africa (all income levels) in 2006 and the Value added (constant 2005 US$) of Antigua and Barbuda in 2008?
Your answer should be very brief. 7.18e+11. What is the difference between the Value added (constant 2005 US$) in Middle East & North Africa (all income levels) in 2006 and the Value added (constant 2005 US$) in Hong Kong in 2008?
Offer a terse response. 5.29e+11. What is the difference between the Value added (constant 2005 US$) of Middle East & North Africa (all income levels) in 2006 and the Value added (constant 2005 US$) of Saudi Arabia in 2008?
Your answer should be very brief. 5.69e+11. What is the difference between the Value added (constant 2005 US$) of Antigua and Barbuda in 2006 and the Value added (constant 2005 US$) of Hong Kong in 2008?
Keep it short and to the point. -1.89e+11. What is the difference between the Value added (constant 2005 US$) of Antigua and Barbuda in 2006 and the Value added (constant 2005 US$) of Saudi Arabia in 2008?
Your answer should be compact. -1.50e+11. What is the difference between the Value added (constant 2005 US$) in Hong Kong in 2006 and the Value added (constant 2005 US$) in Saudi Arabia in 2008?
Your response must be concise. 2.41e+1. What is the difference between the Value added (constant 2005 US$) of Middle East & North Africa (all income levels) in 2006 and the Value added (constant 2005 US$) of Antigua and Barbuda in 2009?
Your answer should be compact. 7.18e+11. What is the difference between the Value added (constant 2005 US$) in Middle East & North Africa (all income levels) in 2006 and the Value added (constant 2005 US$) in Hong Kong in 2009?
Give a very brief answer. 5.33e+11. What is the difference between the Value added (constant 2005 US$) of Middle East & North Africa (all income levels) in 2006 and the Value added (constant 2005 US$) of Saudi Arabia in 2009?
Keep it short and to the point. 5.60e+11. What is the difference between the Value added (constant 2005 US$) of Antigua and Barbuda in 2006 and the Value added (constant 2005 US$) of Hong Kong in 2009?
Provide a succinct answer. -1.85e+11. What is the difference between the Value added (constant 2005 US$) of Antigua and Barbuda in 2006 and the Value added (constant 2005 US$) of Saudi Arabia in 2009?
Ensure brevity in your answer.  -1.58e+11. What is the difference between the Value added (constant 2005 US$) of Hong Kong in 2006 and the Value added (constant 2005 US$) of Saudi Arabia in 2009?
Make the answer very short. 1.55e+1. What is the difference between the Value added (constant 2005 US$) in Middle East & North Africa (all income levels) in 2006 and the Value added (constant 2005 US$) in Antigua and Barbuda in 2010?
Provide a short and direct response. 7.18e+11. What is the difference between the Value added (constant 2005 US$) of Middle East & North Africa (all income levels) in 2006 and the Value added (constant 2005 US$) of Hong Kong in 2010?
Offer a terse response. 5.21e+11. What is the difference between the Value added (constant 2005 US$) in Middle East & North Africa (all income levels) in 2006 and the Value added (constant 2005 US$) in Saudi Arabia in 2010?
Your answer should be very brief. 5.46e+11. What is the difference between the Value added (constant 2005 US$) of Antigua and Barbuda in 2006 and the Value added (constant 2005 US$) of Hong Kong in 2010?
Give a very brief answer. -1.97e+11. What is the difference between the Value added (constant 2005 US$) of Antigua and Barbuda in 2006 and the Value added (constant 2005 US$) of Saudi Arabia in 2010?
Offer a terse response. -1.73e+11. What is the difference between the Value added (constant 2005 US$) of Hong Kong in 2006 and the Value added (constant 2005 US$) of Saudi Arabia in 2010?
Provide a succinct answer. 1.20e+09. What is the difference between the Value added (constant 2005 US$) in Middle East & North Africa (all income levels) in 2007 and the Value added (constant 2005 US$) in Antigua and Barbuda in 2008?
Keep it short and to the point. 7.87e+11. What is the difference between the Value added (constant 2005 US$) of Middle East & North Africa (all income levels) in 2007 and the Value added (constant 2005 US$) of Hong Kong in 2008?
Provide a succinct answer. 5.99e+11. What is the difference between the Value added (constant 2005 US$) in Middle East & North Africa (all income levels) in 2007 and the Value added (constant 2005 US$) in Saudi Arabia in 2008?
Keep it short and to the point. 6.38e+11. What is the difference between the Value added (constant 2005 US$) of Antigua and Barbuda in 2007 and the Value added (constant 2005 US$) of Hong Kong in 2008?
Offer a very short reply. -1.89e+11. What is the difference between the Value added (constant 2005 US$) in Antigua and Barbuda in 2007 and the Value added (constant 2005 US$) in Saudi Arabia in 2008?
Provide a short and direct response. -1.50e+11. What is the difference between the Value added (constant 2005 US$) of Hong Kong in 2007 and the Value added (constant 2005 US$) of Saudi Arabia in 2008?
Your answer should be compact. 3.47e+1. What is the difference between the Value added (constant 2005 US$) of Middle East & North Africa (all income levels) in 2007 and the Value added (constant 2005 US$) of Antigua and Barbuda in 2009?
Provide a succinct answer. 7.88e+11. What is the difference between the Value added (constant 2005 US$) of Middle East & North Africa (all income levels) in 2007 and the Value added (constant 2005 US$) of Hong Kong in 2009?
Your answer should be very brief. 6.03e+11. What is the difference between the Value added (constant 2005 US$) in Middle East & North Africa (all income levels) in 2007 and the Value added (constant 2005 US$) in Saudi Arabia in 2009?
Make the answer very short. 6.29e+11. What is the difference between the Value added (constant 2005 US$) in Antigua and Barbuda in 2007 and the Value added (constant 2005 US$) in Hong Kong in 2009?
Offer a terse response. -1.85e+11. What is the difference between the Value added (constant 2005 US$) of Antigua and Barbuda in 2007 and the Value added (constant 2005 US$) of Saudi Arabia in 2009?
Provide a succinct answer. -1.58e+11. What is the difference between the Value added (constant 2005 US$) of Hong Kong in 2007 and the Value added (constant 2005 US$) of Saudi Arabia in 2009?
Offer a terse response. 2.61e+1. What is the difference between the Value added (constant 2005 US$) of Middle East & North Africa (all income levels) in 2007 and the Value added (constant 2005 US$) of Antigua and Barbuda in 2010?
Offer a terse response. 7.88e+11. What is the difference between the Value added (constant 2005 US$) in Middle East & North Africa (all income levels) in 2007 and the Value added (constant 2005 US$) in Hong Kong in 2010?
Your answer should be very brief. 5.90e+11. What is the difference between the Value added (constant 2005 US$) of Middle East & North Africa (all income levels) in 2007 and the Value added (constant 2005 US$) of Saudi Arabia in 2010?
Your answer should be very brief. 6.15e+11. What is the difference between the Value added (constant 2005 US$) of Antigua and Barbuda in 2007 and the Value added (constant 2005 US$) of Hong Kong in 2010?
Your response must be concise. -1.97e+11. What is the difference between the Value added (constant 2005 US$) in Antigua and Barbuda in 2007 and the Value added (constant 2005 US$) in Saudi Arabia in 2010?
Offer a terse response. -1.72e+11. What is the difference between the Value added (constant 2005 US$) of Hong Kong in 2007 and the Value added (constant 2005 US$) of Saudi Arabia in 2010?
Give a very brief answer. 1.18e+1. What is the difference between the Value added (constant 2005 US$) of Middle East & North Africa (all income levels) in 2008 and the Value added (constant 2005 US$) of Antigua and Barbuda in 2009?
Offer a terse response. 8.39e+11. What is the difference between the Value added (constant 2005 US$) of Middle East & North Africa (all income levels) in 2008 and the Value added (constant 2005 US$) of Hong Kong in 2009?
Your response must be concise. 6.54e+11. What is the difference between the Value added (constant 2005 US$) of Middle East & North Africa (all income levels) in 2008 and the Value added (constant 2005 US$) of Saudi Arabia in 2009?
Provide a succinct answer. 6.80e+11. What is the difference between the Value added (constant 2005 US$) of Antigua and Barbuda in 2008 and the Value added (constant 2005 US$) of Hong Kong in 2009?
Your answer should be very brief. -1.85e+11. What is the difference between the Value added (constant 2005 US$) in Antigua and Barbuda in 2008 and the Value added (constant 2005 US$) in Saudi Arabia in 2009?
Give a very brief answer. -1.58e+11. What is the difference between the Value added (constant 2005 US$) in Hong Kong in 2008 and the Value added (constant 2005 US$) in Saudi Arabia in 2009?
Make the answer very short. 3.05e+1. What is the difference between the Value added (constant 2005 US$) of Middle East & North Africa (all income levels) in 2008 and the Value added (constant 2005 US$) of Antigua and Barbuda in 2010?
Provide a short and direct response. 8.39e+11. What is the difference between the Value added (constant 2005 US$) in Middle East & North Africa (all income levels) in 2008 and the Value added (constant 2005 US$) in Hong Kong in 2010?
Keep it short and to the point. 6.41e+11. What is the difference between the Value added (constant 2005 US$) in Middle East & North Africa (all income levels) in 2008 and the Value added (constant 2005 US$) in Saudi Arabia in 2010?
Your response must be concise. 6.66e+11. What is the difference between the Value added (constant 2005 US$) in Antigua and Barbuda in 2008 and the Value added (constant 2005 US$) in Hong Kong in 2010?
Offer a terse response. -1.97e+11. What is the difference between the Value added (constant 2005 US$) in Antigua and Barbuda in 2008 and the Value added (constant 2005 US$) in Saudi Arabia in 2010?
Offer a terse response. -1.72e+11. What is the difference between the Value added (constant 2005 US$) of Hong Kong in 2008 and the Value added (constant 2005 US$) of Saudi Arabia in 2010?
Your answer should be very brief. 1.62e+1. What is the difference between the Value added (constant 2005 US$) of Middle East & North Africa (all income levels) in 2009 and the Value added (constant 2005 US$) of Antigua and Barbuda in 2010?
Your answer should be very brief. 8.65e+11. What is the difference between the Value added (constant 2005 US$) of Middle East & North Africa (all income levels) in 2009 and the Value added (constant 2005 US$) of Hong Kong in 2010?
Provide a succinct answer. 6.67e+11. What is the difference between the Value added (constant 2005 US$) of Middle East & North Africa (all income levels) in 2009 and the Value added (constant 2005 US$) of Saudi Arabia in 2010?
Your answer should be compact. 6.92e+11. What is the difference between the Value added (constant 2005 US$) in Antigua and Barbuda in 2009 and the Value added (constant 2005 US$) in Hong Kong in 2010?
Ensure brevity in your answer.  -1.97e+11. What is the difference between the Value added (constant 2005 US$) in Antigua and Barbuda in 2009 and the Value added (constant 2005 US$) in Saudi Arabia in 2010?
Offer a very short reply. -1.73e+11. What is the difference between the Value added (constant 2005 US$) in Hong Kong in 2009 and the Value added (constant 2005 US$) in Saudi Arabia in 2010?
Offer a terse response. 1.22e+1. What is the average Value added (constant 2005 US$) in Middle East & North Africa (all income levels) per year?
Provide a succinct answer. 7.48e+11. What is the average Value added (constant 2005 US$) in Antigua and Barbuda per year?
Your answer should be very brief. 7.28e+08. What is the average Value added (constant 2005 US$) in Hong Kong per year?
Your response must be concise. 1.72e+11. What is the average Value added (constant 2005 US$) of Saudi Arabia per year?
Ensure brevity in your answer.  1.32e+11. In the year 2003, what is the difference between the Value added (constant 2005 US$) of Middle East & North Africa (all income levels) and Value added (constant 2005 US$) of Antigua and Barbuda?
Keep it short and to the point. 5.68e+11. In the year 2003, what is the difference between the Value added (constant 2005 US$) in Middle East & North Africa (all income levels) and Value added (constant 2005 US$) in Hong Kong?
Provide a short and direct response. 4.33e+11. In the year 2003, what is the difference between the Value added (constant 2005 US$) in Middle East & North Africa (all income levels) and Value added (constant 2005 US$) in Saudi Arabia?
Give a very brief answer. 4.71e+11. In the year 2003, what is the difference between the Value added (constant 2005 US$) of Antigua and Barbuda and Value added (constant 2005 US$) of Hong Kong?
Your answer should be compact. -1.35e+11. In the year 2003, what is the difference between the Value added (constant 2005 US$) of Antigua and Barbuda and Value added (constant 2005 US$) of Saudi Arabia?
Offer a very short reply. -9.69e+1. In the year 2003, what is the difference between the Value added (constant 2005 US$) of Hong Kong and Value added (constant 2005 US$) of Saudi Arabia?
Keep it short and to the point. 3.77e+1. In the year 2004, what is the difference between the Value added (constant 2005 US$) in Middle East & North Africa (all income levels) and Value added (constant 2005 US$) in Antigua and Barbuda?
Offer a very short reply. 6.23e+11. In the year 2004, what is the difference between the Value added (constant 2005 US$) in Middle East & North Africa (all income levels) and Value added (constant 2005 US$) in Hong Kong?
Your response must be concise. 4.75e+11. In the year 2004, what is the difference between the Value added (constant 2005 US$) in Middle East & North Africa (all income levels) and Value added (constant 2005 US$) in Saudi Arabia?
Offer a very short reply. 5.18e+11. In the year 2004, what is the difference between the Value added (constant 2005 US$) of Antigua and Barbuda and Value added (constant 2005 US$) of Hong Kong?
Offer a very short reply. -1.48e+11. In the year 2004, what is the difference between the Value added (constant 2005 US$) in Antigua and Barbuda and Value added (constant 2005 US$) in Saudi Arabia?
Make the answer very short. -1.05e+11. In the year 2004, what is the difference between the Value added (constant 2005 US$) of Hong Kong and Value added (constant 2005 US$) of Saudi Arabia?
Your answer should be compact. 4.30e+1. In the year 2005, what is the difference between the Value added (constant 2005 US$) of Middle East & North Africa (all income levels) and Value added (constant 2005 US$) of Antigua and Barbuda?
Your answer should be very brief. 6.67e+11. In the year 2005, what is the difference between the Value added (constant 2005 US$) in Middle East & North Africa (all income levels) and Value added (constant 2005 US$) in Hong Kong?
Offer a very short reply. 5.06e+11. In the year 2005, what is the difference between the Value added (constant 2005 US$) in Middle East & North Africa (all income levels) and Value added (constant 2005 US$) in Saudi Arabia?
Offer a terse response. 5.54e+11. In the year 2005, what is the difference between the Value added (constant 2005 US$) in Antigua and Barbuda and Value added (constant 2005 US$) in Hong Kong?
Offer a very short reply. -1.61e+11. In the year 2005, what is the difference between the Value added (constant 2005 US$) of Antigua and Barbuda and Value added (constant 2005 US$) of Saudi Arabia?
Offer a terse response. -1.13e+11. In the year 2005, what is the difference between the Value added (constant 2005 US$) of Hong Kong and Value added (constant 2005 US$) of Saudi Arabia?
Make the answer very short. 4.77e+1. In the year 2006, what is the difference between the Value added (constant 2005 US$) of Middle East & North Africa (all income levels) and Value added (constant 2005 US$) of Antigua and Barbuda?
Give a very brief answer. 7.18e+11. In the year 2006, what is the difference between the Value added (constant 2005 US$) in Middle East & North Africa (all income levels) and Value added (constant 2005 US$) in Hong Kong?
Offer a terse response. 5.44e+11. In the year 2006, what is the difference between the Value added (constant 2005 US$) in Middle East & North Africa (all income levels) and Value added (constant 2005 US$) in Saudi Arabia?
Your answer should be compact. 5.96e+11. In the year 2006, what is the difference between the Value added (constant 2005 US$) of Antigua and Barbuda and Value added (constant 2005 US$) of Hong Kong?
Make the answer very short. -1.74e+11. In the year 2006, what is the difference between the Value added (constant 2005 US$) in Antigua and Barbuda and Value added (constant 2005 US$) in Saudi Arabia?
Your answer should be compact. -1.22e+11. In the year 2006, what is the difference between the Value added (constant 2005 US$) of Hong Kong and Value added (constant 2005 US$) of Saudi Arabia?
Provide a succinct answer. 5.12e+1. In the year 2007, what is the difference between the Value added (constant 2005 US$) in Middle East & North Africa (all income levels) and Value added (constant 2005 US$) in Antigua and Barbuda?
Give a very brief answer. 7.87e+11. In the year 2007, what is the difference between the Value added (constant 2005 US$) of Middle East & North Africa (all income levels) and Value added (constant 2005 US$) of Hong Kong?
Provide a short and direct response. 6.03e+11. In the year 2007, what is the difference between the Value added (constant 2005 US$) in Middle East & North Africa (all income levels) and Value added (constant 2005 US$) in Saudi Arabia?
Keep it short and to the point. 6.53e+11. In the year 2007, what is the difference between the Value added (constant 2005 US$) of Antigua and Barbuda and Value added (constant 2005 US$) of Hong Kong?
Keep it short and to the point. -1.84e+11. In the year 2007, what is the difference between the Value added (constant 2005 US$) of Antigua and Barbuda and Value added (constant 2005 US$) of Saudi Arabia?
Your answer should be very brief. -1.34e+11. In the year 2007, what is the difference between the Value added (constant 2005 US$) in Hong Kong and Value added (constant 2005 US$) in Saudi Arabia?
Give a very brief answer. 4.99e+1. In the year 2008, what is the difference between the Value added (constant 2005 US$) of Middle East & North Africa (all income levels) and Value added (constant 2005 US$) of Antigua and Barbuda?
Make the answer very short. 8.38e+11. In the year 2008, what is the difference between the Value added (constant 2005 US$) in Middle East & North Africa (all income levels) and Value added (constant 2005 US$) in Hong Kong?
Give a very brief answer. 6.50e+11. In the year 2008, what is the difference between the Value added (constant 2005 US$) of Middle East & North Africa (all income levels) and Value added (constant 2005 US$) of Saudi Arabia?
Give a very brief answer. 6.89e+11. In the year 2008, what is the difference between the Value added (constant 2005 US$) in Antigua and Barbuda and Value added (constant 2005 US$) in Hong Kong?
Give a very brief answer. -1.89e+11. In the year 2008, what is the difference between the Value added (constant 2005 US$) in Antigua and Barbuda and Value added (constant 2005 US$) in Saudi Arabia?
Ensure brevity in your answer.  -1.50e+11. In the year 2008, what is the difference between the Value added (constant 2005 US$) of Hong Kong and Value added (constant 2005 US$) of Saudi Arabia?
Ensure brevity in your answer.  3.91e+1. In the year 2009, what is the difference between the Value added (constant 2005 US$) of Middle East & North Africa (all income levels) and Value added (constant 2005 US$) of Antigua and Barbuda?
Make the answer very short. 8.65e+11. In the year 2009, what is the difference between the Value added (constant 2005 US$) in Middle East & North Africa (all income levels) and Value added (constant 2005 US$) in Hong Kong?
Keep it short and to the point. 6.80e+11. In the year 2009, what is the difference between the Value added (constant 2005 US$) in Middle East & North Africa (all income levels) and Value added (constant 2005 US$) in Saudi Arabia?
Your answer should be compact. 7.06e+11. In the year 2009, what is the difference between the Value added (constant 2005 US$) of Antigua and Barbuda and Value added (constant 2005 US$) of Hong Kong?
Offer a very short reply. -1.85e+11. In the year 2009, what is the difference between the Value added (constant 2005 US$) of Antigua and Barbuda and Value added (constant 2005 US$) of Saudi Arabia?
Your response must be concise. -1.58e+11. In the year 2009, what is the difference between the Value added (constant 2005 US$) of Hong Kong and Value added (constant 2005 US$) of Saudi Arabia?
Your answer should be compact. 2.65e+1. In the year 2010, what is the difference between the Value added (constant 2005 US$) in Middle East & North Africa (all income levels) and Value added (constant 2005 US$) in Antigua and Barbuda?
Offer a very short reply. 9.15e+11. In the year 2010, what is the difference between the Value added (constant 2005 US$) of Middle East & North Africa (all income levels) and Value added (constant 2005 US$) of Hong Kong?
Provide a succinct answer. 7.18e+11. In the year 2010, what is the difference between the Value added (constant 2005 US$) of Middle East & North Africa (all income levels) and Value added (constant 2005 US$) of Saudi Arabia?
Offer a very short reply. 7.43e+11. In the year 2010, what is the difference between the Value added (constant 2005 US$) in Antigua and Barbuda and Value added (constant 2005 US$) in Hong Kong?
Keep it short and to the point. -1.97e+11. In the year 2010, what is the difference between the Value added (constant 2005 US$) in Antigua and Barbuda and Value added (constant 2005 US$) in Saudi Arabia?
Offer a very short reply. -1.73e+11. In the year 2010, what is the difference between the Value added (constant 2005 US$) of Hong Kong and Value added (constant 2005 US$) of Saudi Arabia?
Make the answer very short. 2.46e+1. What is the ratio of the Value added (constant 2005 US$) in Middle East & North Africa (all income levels) in 2003 to that in 2004?
Offer a terse response. 0.91. What is the ratio of the Value added (constant 2005 US$) of Antigua and Barbuda in 2003 to that in 2004?
Give a very brief answer. 0.96. What is the ratio of the Value added (constant 2005 US$) of Hong Kong in 2003 to that in 2004?
Ensure brevity in your answer.  0.91. What is the ratio of the Value added (constant 2005 US$) in Saudi Arabia in 2003 to that in 2004?
Your response must be concise. 0.93. What is the ratio of the Value added (constant 2005 US$) in Middle East & North Africa (all income levels) in 2003 to that in 2005?
Make the answer very short. 0.85. What is the ratio of the Value added (constant 2005 US$) of Antigua and Barbuda in 2003 to that in 2005?
Provide a succinct answer. 0.92. What is the ratio of the Value added (constant 2005 US$) of Hong Kong in 2003 to that in 2005?
Ensure brevity in your answer.  0.84. What is the ratio of the Value added (constant 2005 US$) in Saudi Arabia in 2003 to that in 2005?
Your response must be concise. 0.86. What is the ratio of the Value added (constant 2005 US$) in Middle East & North Africa (all income levels) in 2003 to that in 2006?
Your answer should be compact. 0.79. What is the ratio of the Value added (constant 2005 US$) in Antigua and Barbuda in 2003 to that in 2006?
Make the answer very short. 0.86. What is the ratio of the Value added (constant 2005 US$) of Hong Kong in 2003 to that in 2006?
Offer a terse response. 0.77. What is the ratio of the Value added (constant 2005 US$) of Saudi Arabia in 2003 to that in 2006?
Provide a short and direct response. 0.79. What is the ratio of the Value added (constant 2005 US$) of Middle East & North Africa (all income levels) in 2003 to that in 2007?
Provide a short and direct response. 0.72. What is the ratio of the Value added (constant 2005 US$) of Antigua and Barbuda in 2003 to that in 2007?
Give a very brief answer. 0.8. What is the ratio of the Value added (constant 2005 US$) of Hong Kong in 2003 to that in 2007?
Your answer should be compact. 0.73. What is the ratio of the Value added (constant 2005 US$) of Saudi Arabia in 2003 to that in 2007?
Your answer should be very brief. 0.72. What is the ratio of the Value added (constant 2005 US$) of Middle East & North Africa (all income levels) in 2003 to that in 2008?
Offer a very short reply. 0.68. What is the ratio of the Value added (constant 2005 US$) in Antigua and Barbuda in 2003 to that in 2008?
Give a very brief answer. 0.78. What is the ratio of the Value added (constant 2005 US$) of Hong Kong in 2003 to that in 2008?
Provide a succinct answer. 0.71. What is the ratio of the Value added (constant 2005 US$) in Saudi Arabia in 2003 to that in 2008?
Your answer should be compact. 0.65. What is the ratio of the Value added (constant 2005 US$) of Middle East & North Africa (all income levels) in 2003 to that in 2009?
Ensure brevity in your answer.  0.66. What is the ratio of the Value added (constant 2005 US$) of Antigua and Barbuda in 2003 to that in 2009?
Ensure brevity in your answer.  0.89. What is the ratio of the Value added (constant 2005 US$) of Hong Kong in 2003 to that in 2009?
Provide a succinct answer. 0.73. What is the ratio of the Value added (constant 2005 US$) in Saudi Arabia in 2003 to that in 2009?
Provide a short and direct response. 0.61. What is the ratio of the Value added (constant 2005 US$) of Middle East & North Africa (all income levels) in 2003 to that in 2010?
Give a very brief answer. 0.62. What is the ratio of the Value added (constant 2005 US$) in Antigua and Barbuda in 2003 to that in 2010?
Keep it short and to the point. 0.92. What is the ratio of the Value added (constant 2005 US$) of Hong Kong in 2003 to that in 2010?
Provide a short and direct response. 0.68. What is the ratio of the Value added (constant 2005 US$) in Saudi Arabia in 2003 to that in 2010?
Keep it short and to the point. 0.56. What is the ratio of the Value added (constant 2005 US$) in Middle East & North Africa (all income levels) in 2004 to that in 2005?
Provide a succinct answer. 0.93. What is the ratio of the Value added (constant 2005 US$) of Antigua and Barbuda in 2004 to that in 2005?
Offer a very short reply. 0.96. What is the ratio of the Value added (constant 2005 US$) of Hong Kong in 2004 to that in 2005?
Provide a short and direct response. 0.92. What is the ratio of the Value added (constant 2005 US$) in Saudi Arabia in 2004 to that in 2005?
Give a very brief answer. 0.92. What is the ratio of the Value added (constant 2005 US$) of Middle East & North Africa (all income levels) in 2004 to that in 2006?
Your answer should be very brief. 0.87. What is the ratio of the Value added (constant 2005 US$) in Antigua and Barbuda in 2004 to that in 2006?
Offer a very short reply. 0.89. What is the ratio of the Value added (constant 2005 US$) in Hong Kong in 2004 to that in 2006?
Ensure brevity in your answer.  0.85. What is the ratio of the Value added (constant 2005 US$) of Saudi Arabia in 2004 to that in 2006?
Give a very brief answer. 0.85. What is the ratio of the Value added (constant 2005 US$) in Middle East & North Africa (all income levels) in 2004 to that in 2007?
Ensure brevity in your answer.  0.79. What is the ratio of the Value added (constant 2005 US$) in Antigua and Barbuda in 2004 to that in 2007?
Keep it short and to the point. 0.83. What is the ratio of the Value added (constant 2005 US$) of Hong Kong in 2004 to that in 2007?
Your answer should be compact. 0.8. What is the ratio of the Value added (constant 2005 US$) of Saudi Arabia in 2004 to that in 2007?
Keep it short and to the point. 0.78. What is the ratio of the Value added (constant 2005 US$) in Middle East & North Africa (all income levels) in 2004 to that in 2008?
Your response must be concise. 0.74. What is the ratio of the Value added (constant 2005 US$) of Antigua and Barbuda in 2004 to that in 2008?
Offer a terse response. 0.81. What is the ratio of the Value added (constant 2005 US$) of Hong Kong in 2004 to that in 2008?
Your answer should be compact. 0.78. What is the ratio of the Value added (constant 2005 US$) of Saudi Arabia in 2004 to that in 2008?
Provide a succinct answer. 0.7. What is the ratio of the Value added (constant 2005 US$) of Middle East & North Africa (all income levels) in 2004 to that in 2009?
Give a very brief answer. 0.72. What is the ratio of the Value added (constant 2005 US$) of Antigua and Barbuda in 2004 to that in 2009?
Your response must be concise. 0.92. What is the ratio of the Value added (constant 2005 US$) in Saudi Arabia in 2004 to that in 2009?
Ensure brevity in your answer.  0.66. What is the ratio of the Value added (constant 2005 US$) of Middle East & North Africa (all income levels) in 2004 to that in 2010?
Ensure brevity in your answer.  0.68. What is the ratio of the Value added (constant 2005 US$) in Antigua and Barbuda in 2004 to that in 2010?
Offer a very short reply. 0.96. What is the ratio of the Value added (constant 2005 US$) in Hong Kong in 2004 to that in 2010?
Give a very brief answer. 0.75. What is the ratio of the Value added (constant 2005 US$) in Saudi Arabia in 2004 to that in 2010?
Your answer should be very brief. 0.61. What is the ratio of the Value added (constant 2005 US$) of Middle East & North Africa (all income levels) in 2005 to that in 2006?
Ensure brevity in your answer.  0.93. What is the ratio of the Value added (constant 2005 US$) in Antigua and Barbuda in 2005 to that in 2006?
Give a very brief answer. 0.93. What is the ratio of the Value added (constant 2005 US$) of Hong Kong in 2005 to that in 2006?
Provide a short and direct response. 0.93. What is the ratio of the Value added (constant 2005 US$) in Saudi Arabia in 2005 to that in 2006?
Offer a very short reply. 0.92. What is the ratio of the Value added (constant 2005 US$) of Middle East & North Africa (all income levels) in 2005 to that in 2007?
Your answer should be very brief. 0.85. What is the ratio of the Value added (constant 2005 US$) of Antigua and Barbuda in 2005 to that in 2007?
Provide a short and direct response. 0.87. What is the ratio of the Value added (constant 2005 US$) in Hong Kong in 2005 to that in 2007?
Give a very brief answer. 0.87. What is the ratio of the Value added (constant 2005 US$) of Saudi Arabia in 2005 to that in 2007?
Your answer should be compact. 0.84. What is the ratio of the Value added (constant 2005 US$) of Middle East & North Africa (all income levels) in 2005 to that in 2008?
Your response must be concise. 0.8. What is the ratio of the Value added (constant 2005 US$) in Antigua and Barbuda in 2005 to that in 2008?
Ensure brevity in your answer.  0.85. What is the ratio of the Value added (constant 2005 US$) in Hong Kong in 2005 to that in 2008?
Keep it short and to the point. 0.85. What is the ratio of the Value added (constant 2005 US$) of Saudi Arabia in 2005 to that in 2008?
Offer a very short reply. 0.76. What is the ratio of the Value added (constant 2005 US$) of Middle East & North Africa (all income levels) in 2005 to that in 2009?
Make the answer very short. 0.77. What is the ratio of the Value added (constant 2005 US$) of Antigua and Barbuda in 2005 to that in 2009?
Keep it short and to the point. 0.96. What is the ratio of the Value added (constant 2005 US$) in Hong Kong in 2005 to that in 2009?
Keep it short and to the point. 0.87. What is the ratio of the Value added (constant 2005 US$) of Saudi Arabia in 2005 to that in 2009?
Keep it short and to the point. 0.72. What is the ratio of the Value added (constant 2005 US$) of Middle East & North Africa (all income levels) in 2005 to that in 2010?
Ensure brevity in your answer.  0.73. What is the ratio of the Value added (constant 2005 US$) of Hong Kong in 2005 to that in 2010?
Provide a short and direct response. 0.82. What is the ratio of the Value added (constant 2005 US$) in Saudi Arabia in 2005 to that in 2010?
Keep it short and to the point. 0.66. What is the ratio of the Value added (constant 2005 US$) of Middle East & North Africa (all income levels) in 2006 to that in 2007?
Offer a very short reply. 0.91. What is the ratio of the Value added (constant 2005 US$) in Antigua and Barbuda in 2006 to that in 2007?
Offer a terse response. 0.93. What is the ratio of the Value added (constant 2005 US$) in Hong Kong in 2006 to that in 2007?
Provide a succinct answer. 0.94. What is the ratio of the Value added (constant 2005 US$) in Saudi Arabia in 2006 to that in 2007?
Your answer should be compact. 0.91. What is the ratio of the Value added (constant 2005 US$) in Middle East & North Africa (all income levels) in 2006 to that in 2008?
Give a very brief answer. 0.86. What is the ratio of the Value added (constant 2005 US$) in Antigua and Barbuda in 2006 to that in 2008?
Make the answer very short. 0.92. What is the ratio of the Value added (constant 2005 US$) of Hong Kong in 2006 to that in 2008?
Give a very brief answer. 0.92. What is the ratio of the Value added (constant 2005 US$) in Saudi Arabia in 2006 to that in 2008?
Make the answer very short. 0.82. What is the ratio of the Value added (constant 2005 US$) of Middle East & North Africa (all income levels) in 2006 to that in 2009?
Give a very brief answer. 0.83. What is the ratio of the Value added (constant 2005 US$) in Antigua and Barbuda in 2006 to that in 2009?
Provide a succinct answer. 1.04. What is the ratio of the Value added (constant 2005 US$) of Hong Kong in 2006 to that in 2009?
Your answer should be very brief. 0.94. What is the ratio of the Value added (constant 2005 US$) of Saudi Arabia in 2006 to that in 2009?
Ensure brevity in your answer.  0.78. What is the ratio of the Value added (constant 2005 US$) in Middle East & North Africa (all income levels) in 2006 to that in 2010?
Give a very brief answer. 0.78. What is the ratio of the Value added (constant 2005 US$) of Hong Kong in 2006 to that in 2010?
Give a very brief answer. 0.88. What is the ratio of the Value added (constant 2005 US$) in Saudi Arabia in 2006 to that in 2010?
Offer a very short reply. 0.71. What is the ratio of the Value added (constant 2005 US$) of Middle East & North Africa (all income levels) in 2007 to that in 2008?
Give a very brief answer. 0.94. What is the ratio of the Value added (constant 2005 US$) of Antigua and Barbuda in 2007 to that in 2008?
Make the answer very short. 0.98. What is the ratio of the Value added (constant 2005 US$) in Hong Kong in 2007 to that in 2008?
Keep it short and to the point. 0.98. What is the ratio of the Value added (constant 2005 US$) in Saudi Arabia in 2007 to that in 2008?
Your answer should be compact. 0.9. What is the ratio of the Value added (constant 2005 US$) of Middle East & North Africa (all income levels) in 2007 to that in 2009?
Give a very brief answer. 0.91. What is the ratio of the Value added (constant 2005 US$) in Antigua and Barbuda in 2007 to that in 2009?
Keep it short and to the point. 1.11. What is the ratio of the Value added (constant 2005 US$) of Hong Kong in 2007 to that in 2009?
Ensure brevity in your answer.  1. What is the ratio of the Value added (constant 2005 US$) of Saudi Arabia in 2007 to that in 2009?
Ensure brevity in your answer.  0.85. What is the ratio of the Value added (constant 2005 US$) in Middle East & North Africa (all income levels) in 2007 to that in 2010?
Your answer should be compact. 0.86. What is the ratio of the Value added (constant 2005 US$) in Antigua and Barbuda in 2007 to that in 2010?
Offer a very short reply. 1.15. What is the ratio of the Value added (constant 2005 US$) of Hong Kong in 2007 to that in 2010?
Your response must be concise. 0.94. What is the ratio of the Value added (constant 2005 US$) in Saudi Arabia in 2007 to that in 2010?
Your answer should be very brief. 0.78. What is the ratio of the Value added (constant 2005 US$) of Middle East & North Africa (all income levels) in 2008 to that in 2009?
Make the answer very short. 0.97. What is the ratio of the Value added (constant 2005 US$) of Antigua and Barbuda in 2008 to that in 2009?
Offer a very short reply. 1.13. What is the ratio of the Value added (constant 2005 US$) in Hong Kong in 2008 to that in 2009?
Provide a short and direct response. 1.02. What is the ratio of the Value added (constant 2005 US$) of Saudi Arabia in 2008 to that in 2009?
Offer a terse response. 0.95. What is the ratio of the Value added (constant 2005 US$) of Middle East & North Africa (all income levels) in 2008 to that in 2010?
Make the answer very short. 0.92. What is the ratio of the Value added (constant 2005 US$) in Antigua and Barbuda in 2008 to that in 2010?
Provide a short and direct response. 1.18. What is the ratio of the Value added (constant 2005 US$) in Hong Kong in 2008 to that in 2010?
Your answer should be very brief. 0.96. What is the ratio of the Value added (constant 2005 US$) of Saudi Arabia in 2008 to that in 2010?
Keep it short and to the point. 0.87. What is the ratio of the Value added (constant 2005 US$) in Middle East & North Africa (all income levels) in 2009 to that in 2010?
Your answer should be very brief. 0.94. What is the ratio of the Value added (constant 2005 US$) of Antigua and Barbuda in 2009 to that in 2010?
Your answer should be very brief. 1.04. What is the ratio of the Value added (constant 2005 US$) of Hong Kong in 2009 to that in 2010?
Your answer should be compact. 0.94. What is the ratio of the Value added (constant 2005 US$) of Saudi Arabia in 2009 to that in 2010?
Offer a terse response. 0.92. What is the difference between the highest and the second highest Value added (constant 2005 US$) in Middle East & North Africa (all income levels)?
Provide a short and direct response. 5.06e+1. What is the difference between the highest and the second highest Value added (constant 2005 US$) of Antigua and Barbuda?
Ensure brevity in your answer.  1.68e+07. What is the difference between the highest and the second highest Value added (constant 2005 US$) in Hong Kong?
Your answer should be compact. 8.41e+09. What is the difference between the highest and the second highest Value added (constant 2005 US$) of Saudi Arabia?
Your answer should be compact. 1.43e+1. What is the difference between the highest and the lowest Value added (constant 2005 US$) in Middle East & North Africa (all income levels)?
Keep it short and to the point. 3.47e+11. What is the difference between the highest and the lowest Value added (constant 2005 US$) of Antigua and Barbuda?
Give a very brief answer. 1.78e+08. What is the difference between the highest and the lowest Value added (constant 2005 US$) in Hong Kong?
Provide a succinct answer. 6.27e+1. What is the difference between the highest and the lowest Value added (constant 2005 US$) in Saudi Arabia?
Your answer should be very brief. 7.58e+1. 